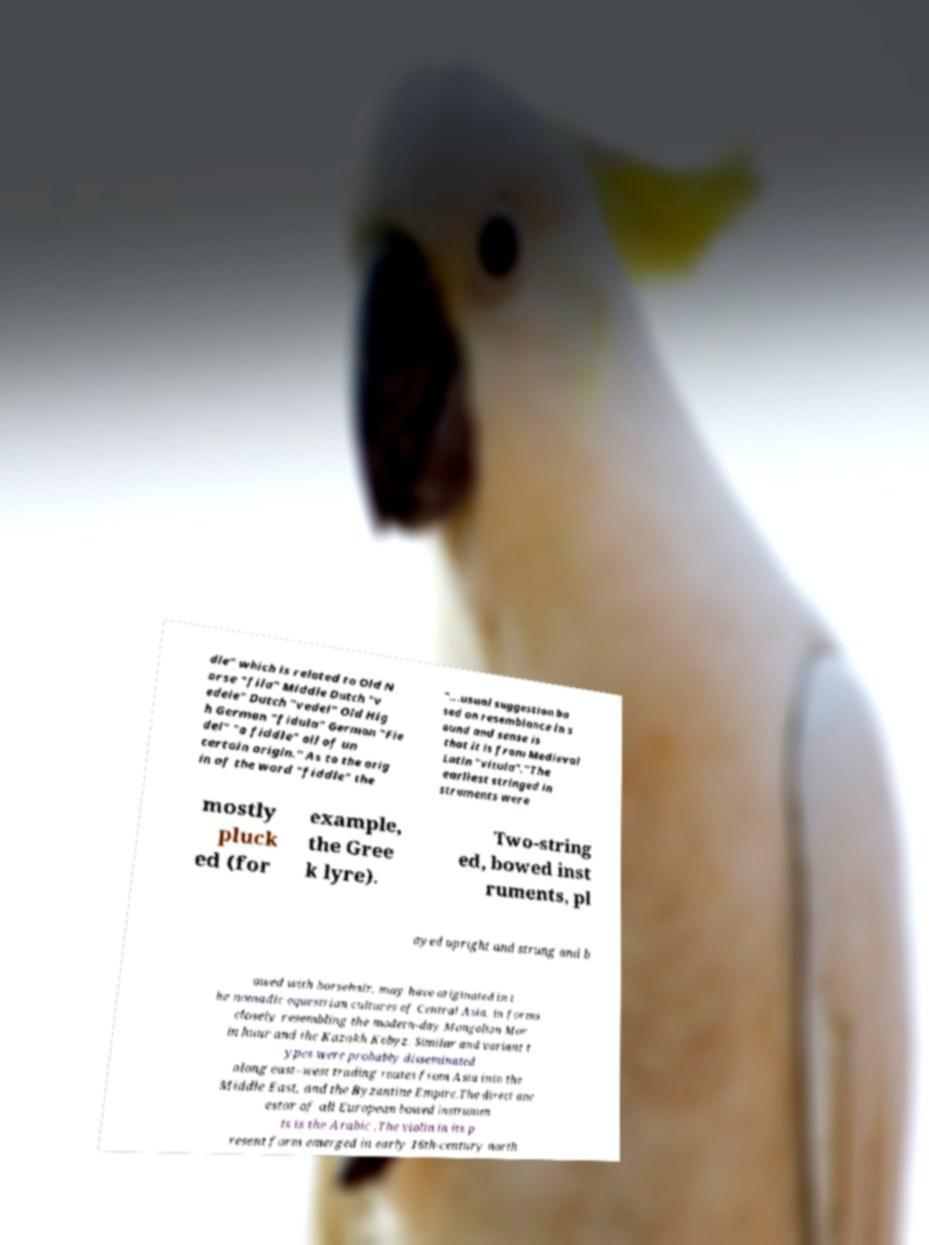There's text embedded in this image that I need extracted. Can you transcribe it verbatim? dle" which is related to Old N orse "fila" Middle Dutch "v edele" Dutch "vedel" Old Hig h German "fidula" German "Fie del" "a fiddle" all of un certain origin." As to the orig in of the word "fiddle" the "...usual suggestion ba sed on resemblance in s ound and sense is that it is from Medieval Latin "vitula"."The earliest stringed in struments were mostly pluck ed (for example, the Gree k lyre). Two-string ed, bowed inst ruments, pl ayed upright and strung and b owed with horsehair, may have originated in t he nomadic equestrian cultures of Central Asia, in forms closely resembling the modern-day Mongolian Mor in huur and the Kazakh Kobyz. Similar and variant t ypes were probably disseminated along east–west trading routes from Asia into the Middle East, and the Byzantine Empire.The direct anc estor of all European bowed instrumen ts is the Arabic .The violin in its p resent form emerged in early 16th-century north 